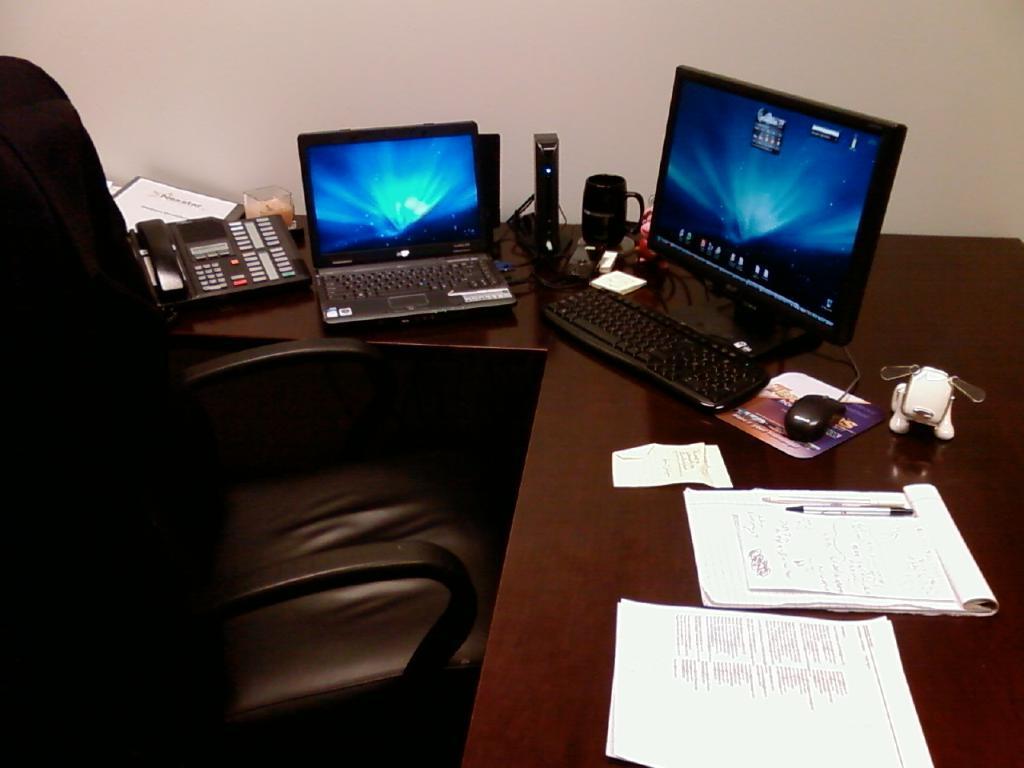How would you summarize this image in a sentence or two? There is a chair in front of a table which has a computer,laptop,papers and some other objects on it 